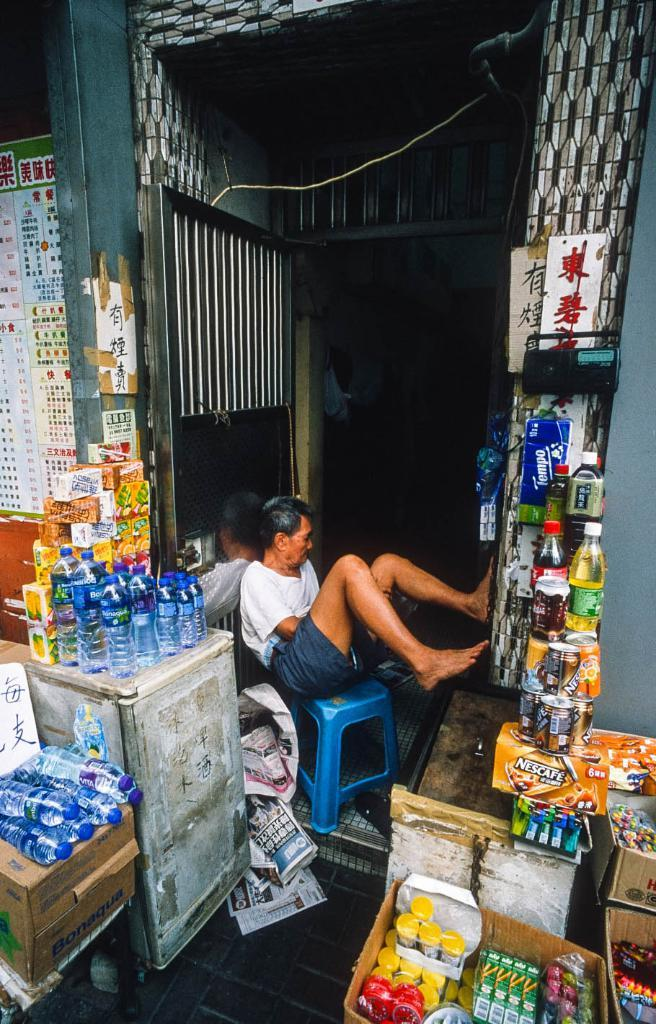<image>
Offer a succinct explanation of the picture presented. A man sitting on a blue chair and selling goods, including a package of Nescafe. 